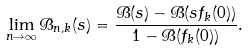Convert formula to latex. <formula><loc_0><loc_0><loc_500><loc_500>\lim _ { n \rightarrow \infty } \mathcal { B } _ { n , k } ( s ) = \frac { \mathcal { B } ( s ) - \mathcal { B } ( s f _ { k } ( 0 ) ) } { 1 - \mathcal { B } ( f _ { k } ( 0 ) ) } .</formula> 